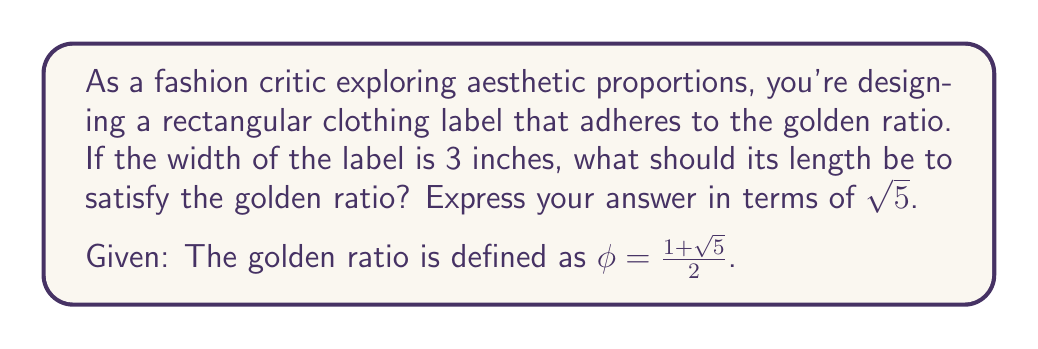Can you solve this math problem? Let's approach this step-by-step:

1) The golden ratio $\phi$ is defined as the ratio of the longer side to the shorter side. If we denote the length as $l$ and the width as $w$, we have:

   $$\frac{l}{w} = \phi = \frac{1+\sqrt{5}}{2}$$

2) We're given that the width $w = 3$ inches. Let's substitute this into our equation:

   $$\frac{l}{3} = \frac{1+\sqrt{5}}{2}$$

3) To solve for $l$, we multiply both sides by 3:

   $$l = 3 \cdot \frac{1+\sqrt{5}}{2}$$

4) Simplify:

   $$l = \frac{3+3\sqrt{5}}{2}$$

5) To express this in terms of $\sqrt{5}$ as requested, let's separate the rational and irrational parts:

   $$l = \frac{3}{2} + \frac{3\sqrt{5}}{2}$$

This is our final answer, but we can verify that it indeed satisfies the golden ratio:

$$\frac{l}{w} = \frac{\frac{3}{2} + \frac{3\sqrt{5}}{2}}{3} = \frac{1}{2} + \frac{\sqrt{5}}{2} = \frac{1+\sqrt{5}}{2} = \phi$$

Thus, our solution is correct.
Answer: $l = \frac{3}{2} + \frac{3\sqrt{5}}{2}$ inches 